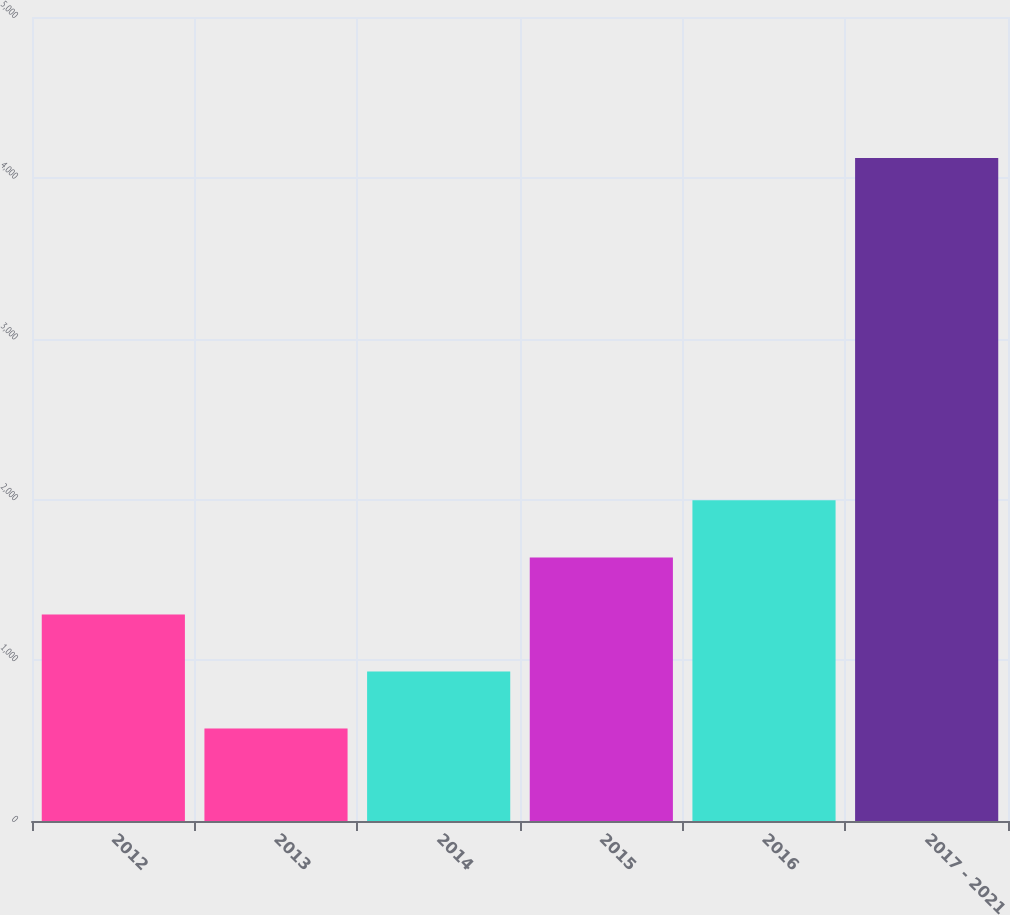<chart> <loc_0><loc_0><loc_500><loc_500><bar_chart><fcel>2012<fcel>2013<fcel>2014<fcel>2015<fcel>2016<fcel>2017 - 2021<nl><fcel>1284.6<fcel>575<fcel>929.8<fcel>1639.4<fcel>1994.2<fcel>4123<nl></chart> 